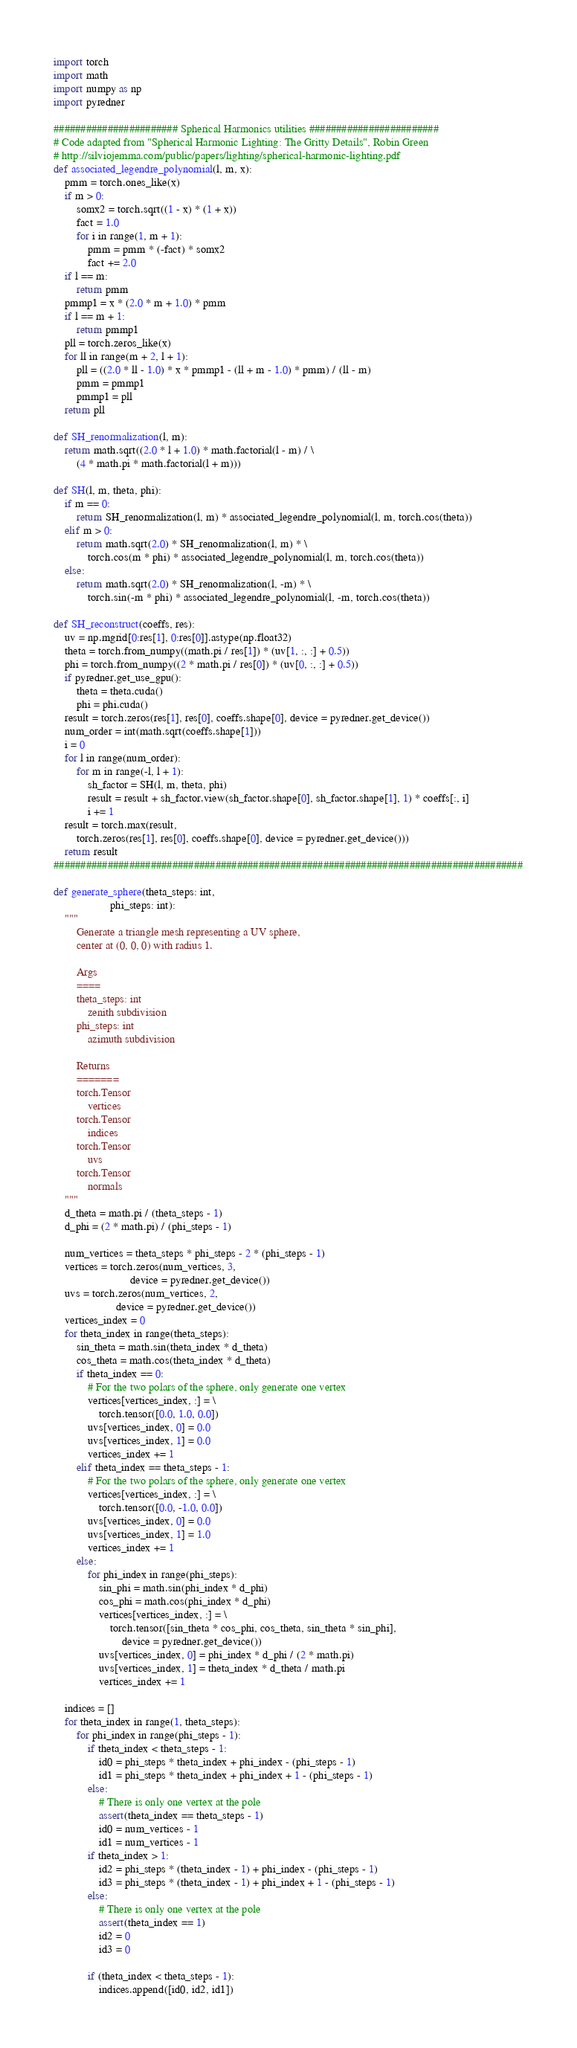<code> <loc_0><loc_0><loc_500><loc_500><_Python_>import torch
import math
import numpy as np
import pyredner

####################### Spherical Harmonics utilities ########################
# Code adapted from "Spherical Harmonic Lighting: The Gritty Details", Robin Green
# http://silviojemma.com/public/papers/lighting/spherical-harmonic-lighting.pdf
def associated_legendre_polynomial(l, m, x):
    pmm = torch.ones_like(x)
    if m > 0:
        somx2 = torch.sqrt((1 - x) * (1 + x))
        fact = 1.0
        for i in range(1, m + 1):
            pmm = pmm * (-fact) * somx2
            fact += 2.0
    if l == m:
        return pmm
    pmmp1 = x * (2.0 * m + 1.0) * pmm
    if l == m + 1:
        return pmmp1
    pll = torch.zeros_like(x)
    for ll in range(m + 2, l + 1):
        pll = ((2.0 * ll - 1.0) * x * pmmp1 - (ll + m - 1.0) * pmm) / (ll - m)
        pmm = pmmp1
        pmmp1 = pll
    return pll

def SH_renormalization(l, m):
    return math.sqrt((2.0 * l + 1.0) * math.factorial(l - m) / \
        (4 * math.pi * math.factorial(l + m)))

def SH(l, m, theta, phi):
    if m == 0:
        return SH_renormalization(l, m) * associated_legendre_polynomial(l, m, torch.cos(theta))
    elif m > 0:
        return math.sqrt(2.0) * SH_renormalization(l, m) * \
            torch.cos(m * phi) * associated_legendre_polynomial(l, m, torch.cos(theta))
    else:
        return math.sqrt(2.0) * SH_renormalization(l, -m) * \
            torch.sin(-m * phi) * associated_legendre_polynomial(l, -m, torch.cos(theta))

def SH_reconstruct(coeffs, res):
    uv = np.mgrid[0:res[1], 0:res[0]].astype(np.float32)
    theta = torch.from_numpy((math.pi / res[1]) * (uv[1, :, :] + 0.5))
    phi = torch.from_numpy((2 * math.pi / res[0]) * (uv[0, :, :] + 0.5))
    if pyredner.get_use_gpu():
        theta = theta.cuda()
        phi = phi.cuda()
    result = torch.zeros(res[1], res[0], coeffs.shape[0], device = pyredner.get_device())
    num_order = int(math.sqrt(coeffs.shape[1]))
    i = 0
    for l in range(num_order):
        for m in range(-l, l + 1):
            sh_factor = SH(l, m, theta, phi)
            result = result + sh_factor.view(sh_factor.shape[0], sh_factor.shape[1], 1) * coeffs[:, i]
            i += 1
    result = torch.max(result,
        torch.zeros(res[1], res[0], coeffs.shape[0], device = pyredner.get_device()))
    return result
#######################################################################################

def generate_sphere(theta_steps: int,
                    phi_steps: int):
    """
        Generate a triangle mesh representing a UV sphere,
        center at (0, 0, 0) with radius 1.

        Args
        ====
        theta_steps: int
            zenith subdivision
        phi_steps: int
            azimuth subdivision

        Returns
        =======
        torch.Tensor
            vertices
        torch.Tensor
            indices
        torch.Tensor
            uvs
        torch.Tensor
            normals
    """
    d_theta = math.pi / (theta_steps - 1)
    d_phi = (2 * math.pi) / (phi_steps - 1)

    num_vertices = theta_steps * phi_steps - 2 * (phi_steps - 1)
    vertices = torch.zeros(num_vertices, 3,
                           device = pyredner.get_device())
    uvs = torch.zeros(num_vertices, 2,
                      device = pyredner.get_device())
    vertices_index = 0
    for theta_index in range(theta_steps):
        sin_theta = math.sin(theta_index * d_theta)
        cos_theta = math.cos(theta_index * d_theta)
        if theta_index == 0:
            # For the two polars of the sphere, only generate one vertex
            vertices[vertices_index, :] = \
                torch.tensor([0.0, 1.0, 0.0])
            uvs[vertices_index, 0] = 0.0
            uvs[vertices_index, 1] = 0.0
            vertices_index += 1
        elif theta_index == theta_steps - 1:
            # For the two polars of the sphere, only generate one vertex
            vertices[vertices_index, :] = \
                torch.tensor([0.0, -1.0, 0.0])
            uvs[vertices_index, 0] = 0.0
            uvs[vertices_index, 1] = 1.0
            vertices_index += 1
        else:
            for phi_index in range(phi_steps):
                sin_phi = math.sin(phi_index * d_phi)
                cos_phi = math.cos(phi_index * d_phi)
                vertices[vertices_index, :] = \
                    torch.tensor([sin_theta * cos_phi, cos_theta, sin_theta * sin_phi],
                        device = pyredner.get_device())
                uvs[vertices_index, 0] = phi_index * d_phi / (2 * math.pi)
                uvs[vertices_index, 1] = theta_index * d_theta / math.pi
                vertices_index += 1

    indices = []
    for theta_index in range(1, theta_steps):
        for phi_index in range(phi_steps - 1):
            if theta_index < theta_steps - 1:
                id0 = phi_steps * theta_index + phi_index - (phi_steps - 1)
                id1 = phi_steps * theta_index + phi_index + 1 - (phi_steps - 1)
            else:
                # There is only one vertex at the pole
                assert(theta_index == theta_steps - 1)
                id0 = num_vertices - 1
                id1 = num_vertices - 1
            if theta_index > 1:
                id2 = phi_steps * (theta_index - 1) + phi_index - (phi_steps - 1)
                id3 = phi_steps * (theta_index - 1) + phi_index + 1 - (phi_steps - 1)
            else:
                # There is only one vertex at the pole
                assert(theta_index == 1)
                id2 = 0
                id3 = 0

            if (theta_index < theta_steps - 1):
                indices.append([id0, id2, id1])</code> 